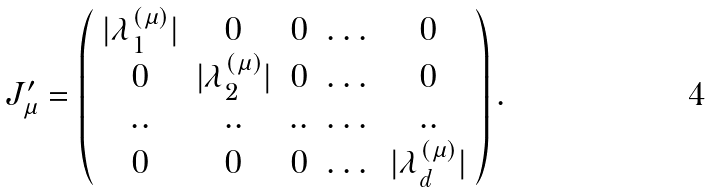Convert formula to latex. <formula><loc_0><loc_0><loc_500><loc_500>J ^ { \prime } _ { \mu } = \left ( \begin{array} { c c c c c c c c c } | \lambda _ { 1 } ^ { ( \mu ) } | & 0 & 0 & \dots & 0 \\ 0 & | \lambda _ { 2 } ^ { ( \mu ) } | & 0 & \dots & 0 \\ . . & . . & . . & \dots & . . \\ 0 & 0 & 0 & \dots & | \lambda _ { d } ^ { ( \mu ) } | \end{array} \right ) .</formula> 